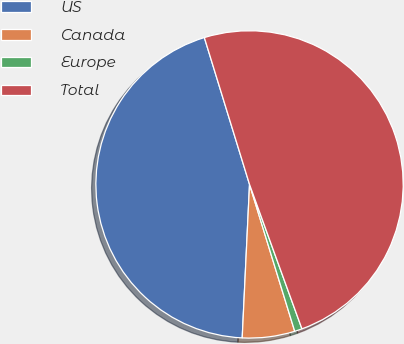Convert chart. <chart><loc_0><loc_0><loc_500><loc_500><pie_chart><fcel>US<fcel>Canada<fcel>Europe<fcel>Total<nl><fcel>44.49%<fcel>5.51%<fcel>0.79%<fcel>49.21%<nl></chart> 